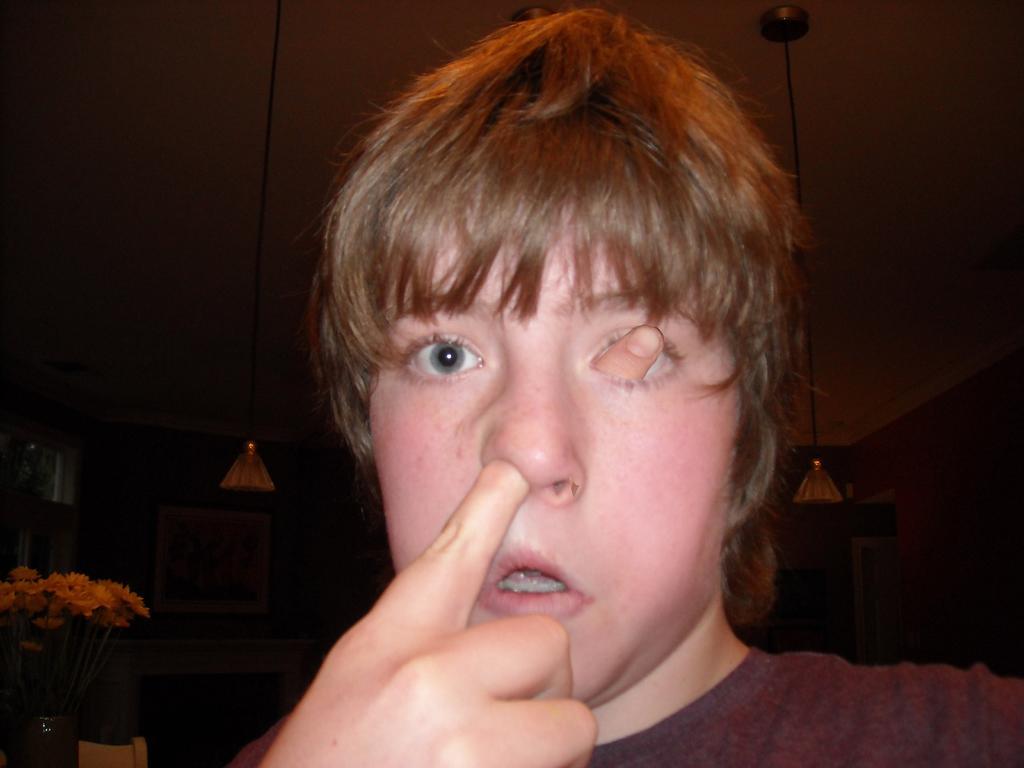Describe this image in one or two sentences. In this image, I can see a person. In the background, I can see the lamps hanging to the ceiling and a photo frame attached to the wall. At the bottom left side of the image, there is a flower vase with a bunch of flowers and an object. 